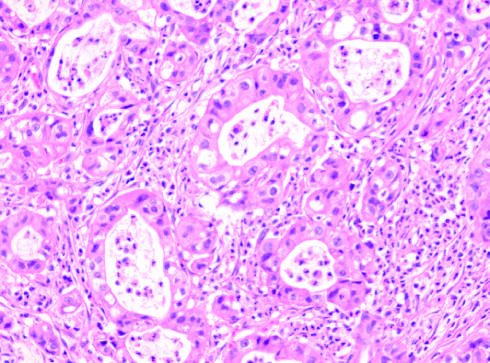what does the tumor have that is the same as intrahepatic cholangiocarcinoma?
Answer the question using a single word or phrase. Appearance 